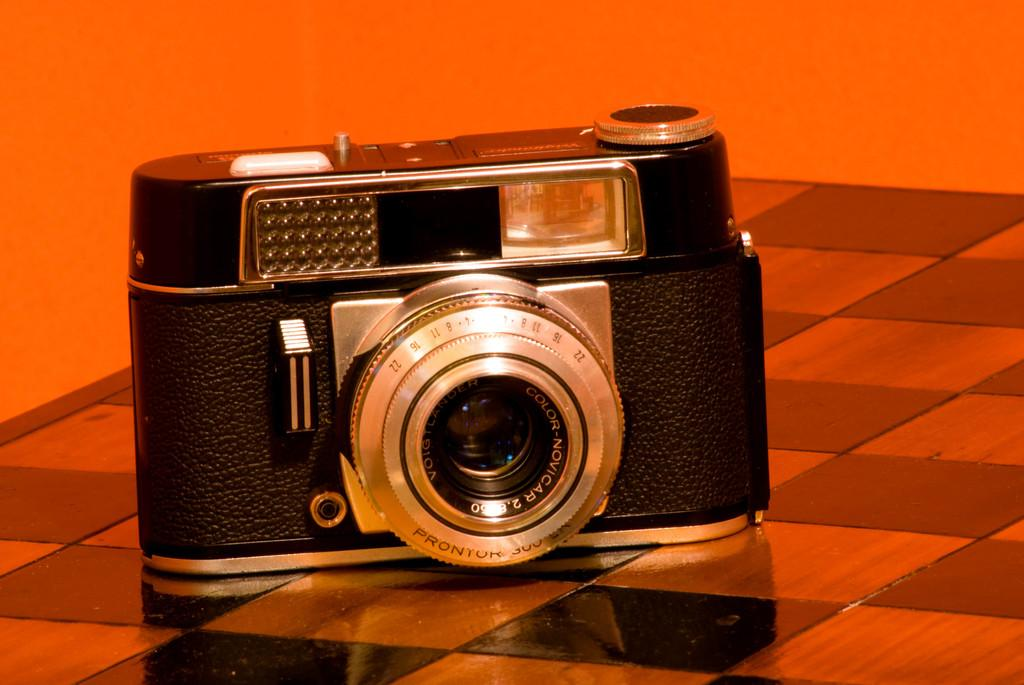What is the main subject of the picture? The main subject of the picture is a black color camera. What can be seen in the background of the picture? There is an orange color wall in the background of the picture. What type of light is being discussed in the image? There is no discussion of light in the image; it features a black color camera and an orange color wall in the background. 